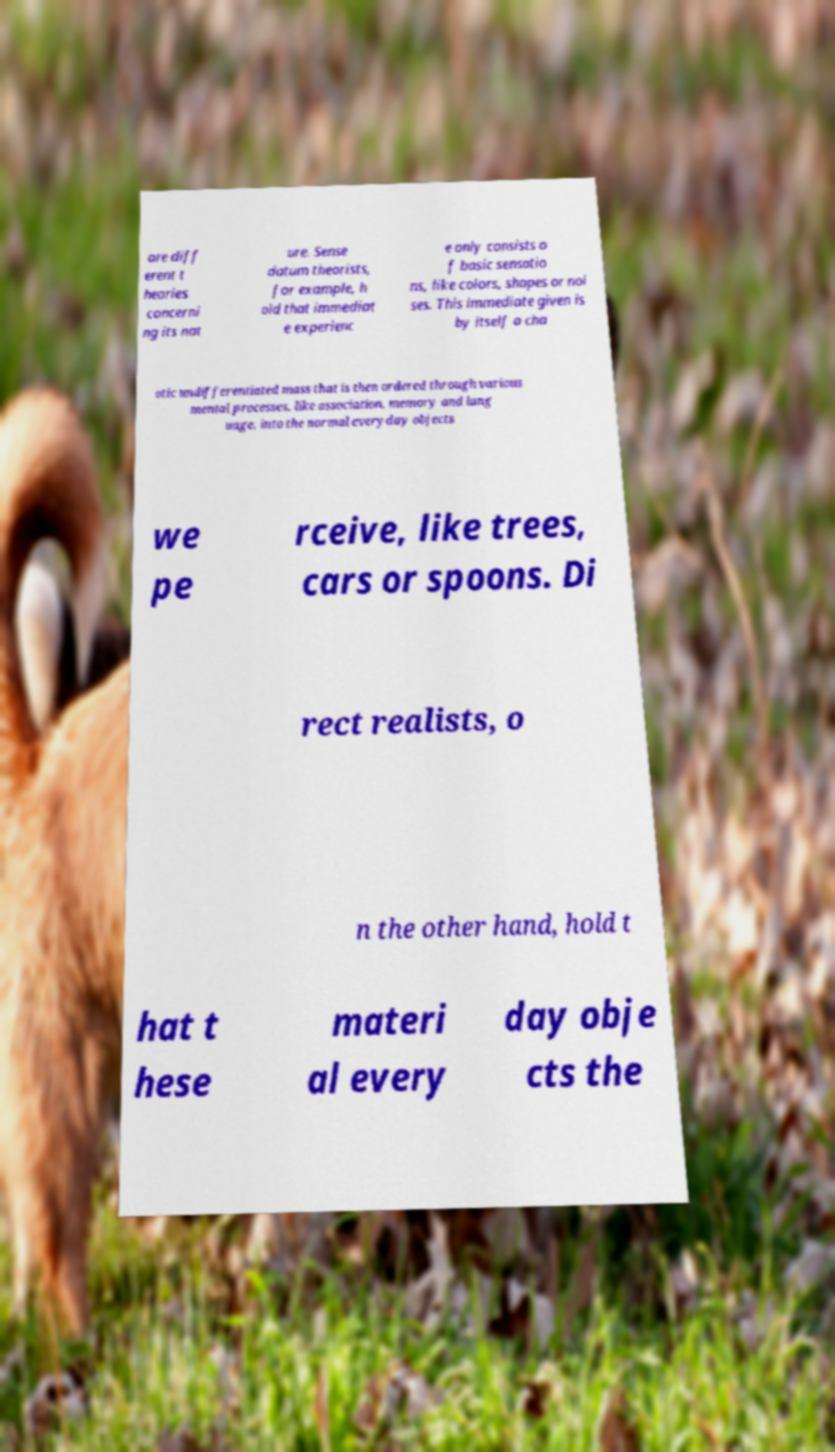Please identify and transcribe the text found in this image. are diff erent t heories concerni ng its nat ure. Sense datum theorists, for example, h old that immediat e experienc e only consists o f basic sensatio ns, like colors, shapes or noi ses. This immediate given is by itself a cha otic undifferentiated mass that is then ordered through various mental processes, like association, memory and lang uage, into the normal everyday objects we pe rceive, like trees, cars or spoons. Di rect realists, o n the other hand, hold t hat t hese materi al every day obje cts the 